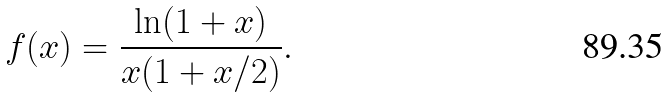Convert formula to latex. <formula><loc_0><loc_0><loc_500><loc_500>f ( x ) = \frac { \ln ( 1 + x ) } { x ( 1 + x / 2 ) } .</formula> 